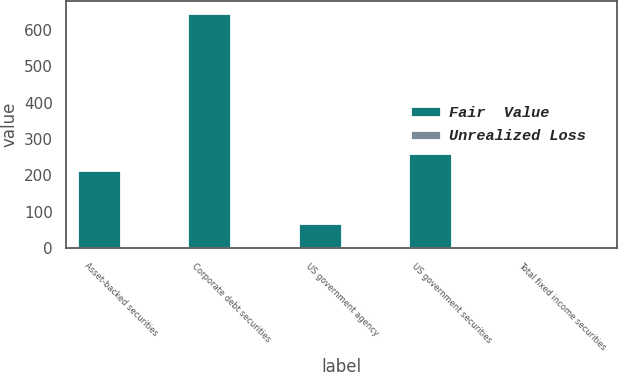Convert chart to OTSL. <chart><loc_0><loc_0><loc_500><loc_500><stacked_bar_chart><ecel><fcel>Asset-backed securities<fcel>Corporate debt securities<fcel>US government agency<fcel>US government securities<fcel>Total fixed income securities<nl><fcel>Fair  Value<fcel>215.2<fcel>646.7<fcel>68.3<fcel>260.8<fcel>3.6<nl><fcel>Unrealized Loss<fcel>0.4<fcel>2.1<fcel>0.2<fcel>0.7<fcel>3.6<nl></chart> 